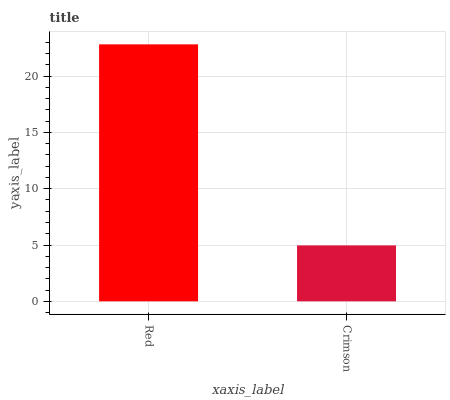Is Crimson the minimum?
Answer yes or no. Yes. Is Red the maximum?
Answer yes or no. Yes. Is Crimson the maximum?
Answer yes or no. No. Is Red greater than Crimson?
Answer yes or no. Yes. Is Crimson less than Red?
Answer yes or no. Yes. Is Crimson greater than Red?
Answer yes or no. No. Is Red less than Crimson?
Answer yes or no. No. Is Red the high median?
Answer yes or no. Yes. Is Crimson the low median?
Answer yes or no. Yes. Is Crimson the high median?
Answer yes or no. No. Is Red the low median?
Answer yes or no. No. 